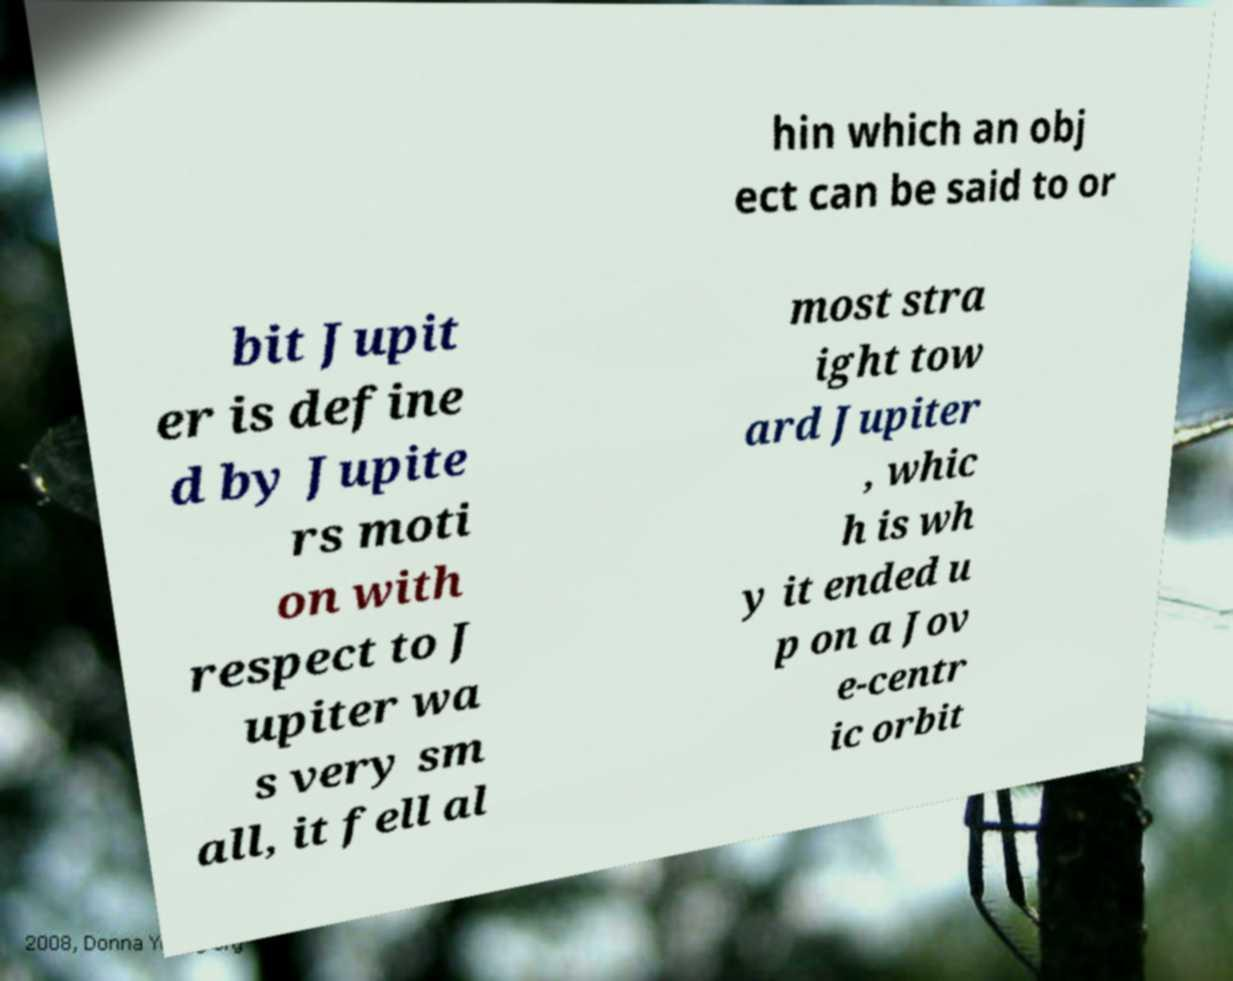For documentation purposes, I need the text within this image transcribed. Could you provide that? hin which an obj ect can be said to or bit Jupit er is define d by Jupite rs moti on with respect to J upiter wa s very sm all, it fell al most stra ight tow ard Jupiter , whic h is wh y it ended u p on a Jov e-centr ic orbit 